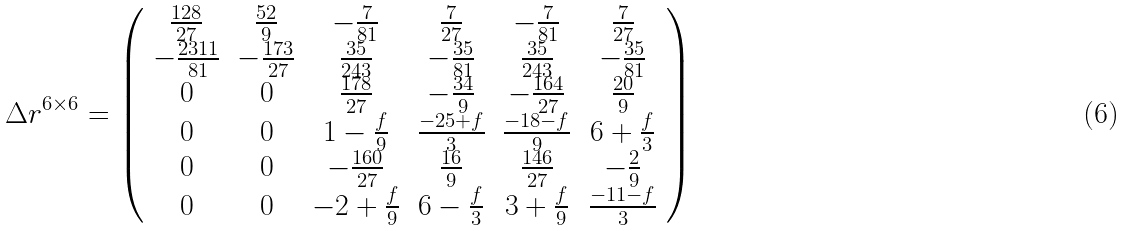Convert formula to latex. <formula><loc_0><loc_0><loc_500><loc_500>\Delta r ^ { 6 \times 6 } = \left ( \begin{array} { c c c c c c } { { \frac { 1 2 8 } { 2 7 } } } & { { \frac { 5 2 } { 9 } } } & { { - \frac { 7 } { 8 1 } } } & { { \frac { 7 } { 2 7 } } } & { { - \frac { 7 } { 8 1 } } } & { { \frac { 7 } { 2 7 } } } \\ { { - \frac { 2 3 1 1 } { 8 1 } } } & { { - \frac { 1 7 3 } { 2 7 } } } & { { \frac { 3 5 } { 2 4 3 } } } & { { - \frac { 3 5 } { 8 1 } } } & { { \frac { 3 5 } { 2 4 3 } } } & { { - \frac { 3 5 } { 8 1 } } } \\ { 0 } & { 0 } & { { \frac { 1 7 8 } { 2 7 } } } & { { - \frac { 3 4 } { 9 } } } & { { - \frac { 1 6 4 } { 2 7 } } } & { { \frac { 2 0 } { 9 } } } \\ { 0 } & { 0 } & { { 1 - \frac { f } { 9 } } } & { { \frac { - 2 5 + f } { 3 } } } & { { \frac { - 1 8 - f } { 9 } } } & { { 6 + \frac { f } { 3 } } } \\ { 0 } & { 0 } & { { - \frac { 1 6 0 } { 2 7 } } } & { { \frac { 1 6 } { 9 } } } & { { \frac { 1 4 6 } { 2 7 } } } & { { - \frac { 2 } { 9 } } } \\ { 0 } & { 0 } & { { - 2 + \frac { f } { 9 } } } & { { 6 - \frac { f } { 3 } } } & { { 3 + \frac { f } { 9 } } } & { { \frac { - 1 1 - f } { 3 } } } \end{array} \right )</formula> 